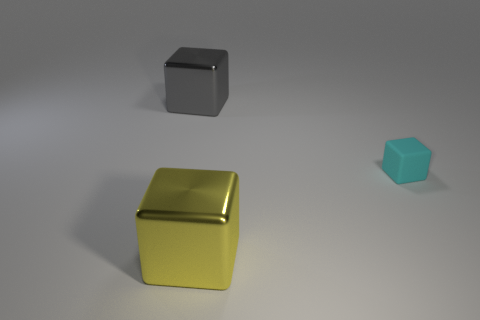There is a thing that is in front of the rubber block; is it the same size as the small cube?
Give a very brief answer. No. How big is the shiny cube that is in front of the big gray metallic cube?
Keep it short and to the point. Large. Are there any other things that have the same material as the big gray cube?
Your answer should be very brief. Yes. How many big yellow metallic cubes are there?
Provide a succinct answer. 1. There is a block that is on the left side of the cyan rubber block and behind the big yellow shiny thing; what is its color?
Your response must be concise. Gray. Are there any large blocks to the right of the tiny cyan block?
Keep it short and to the point. No. What number of yellow cubes are to the left of the big block on the right side of the large gray shiny cube?
Give a very brief answer. 0. What size is the yellow object that is made of the same material as the big gray thing?
Your answer should be compact. Large. What size is the gray cube?
Keep it short and to the point. Large. Are the tiny cube and the large yellow block made of the same material?
Your answer should be compact. No. 